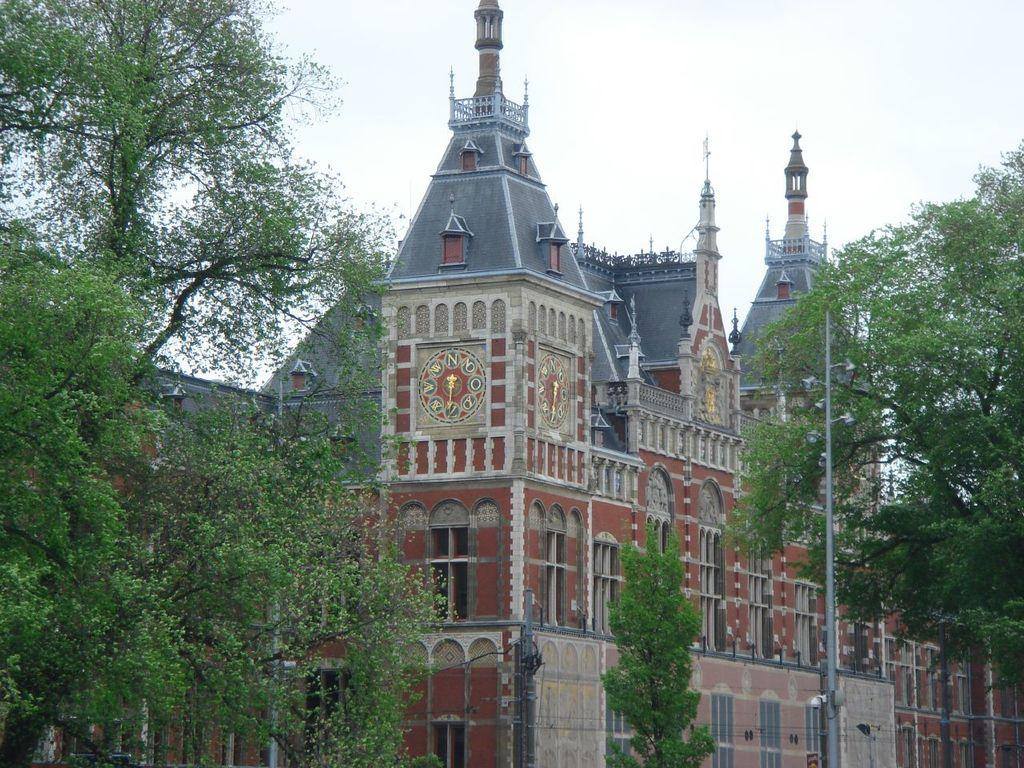What is the main structure in the image? There is a building in the image. What type of vegetation is present on both sides of the building? There are trees on either side of the building. What object can be seen in the right corner of the image? There is a pole in the right corner of the image. What type of furniture is visible in the image? There is no furniture present in the image. What is the temper of the trees on either side of the building? The temper of the trees cannot be determined from the image, as trees do not have emotions. 